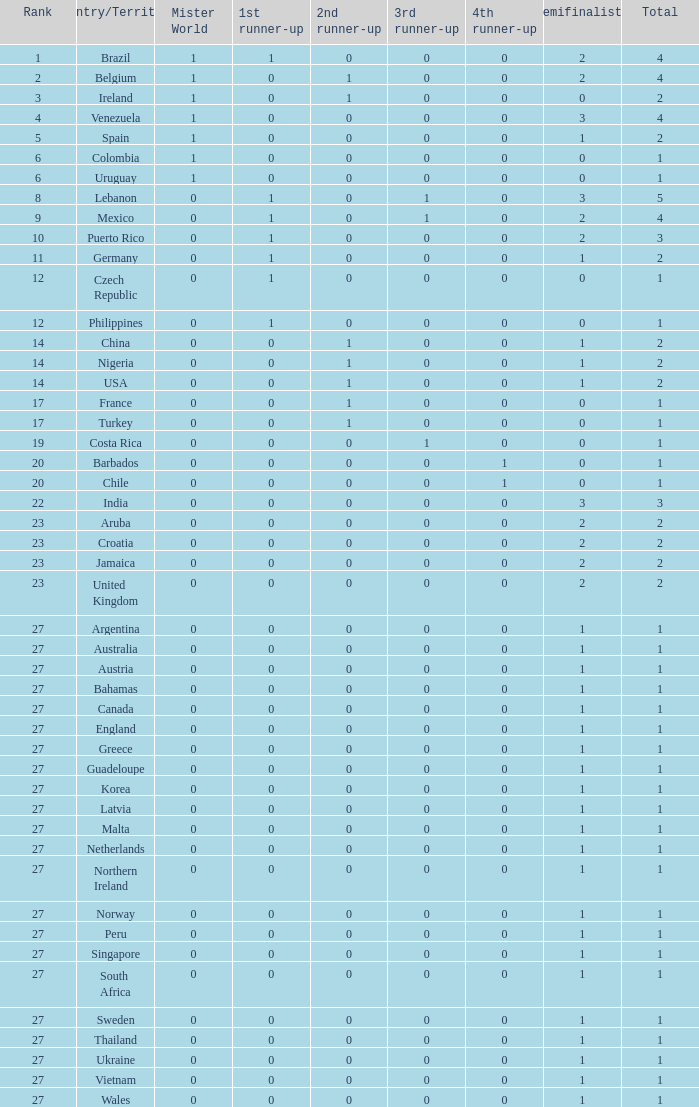What is the most minimal 1st runner up value? 0.0. 